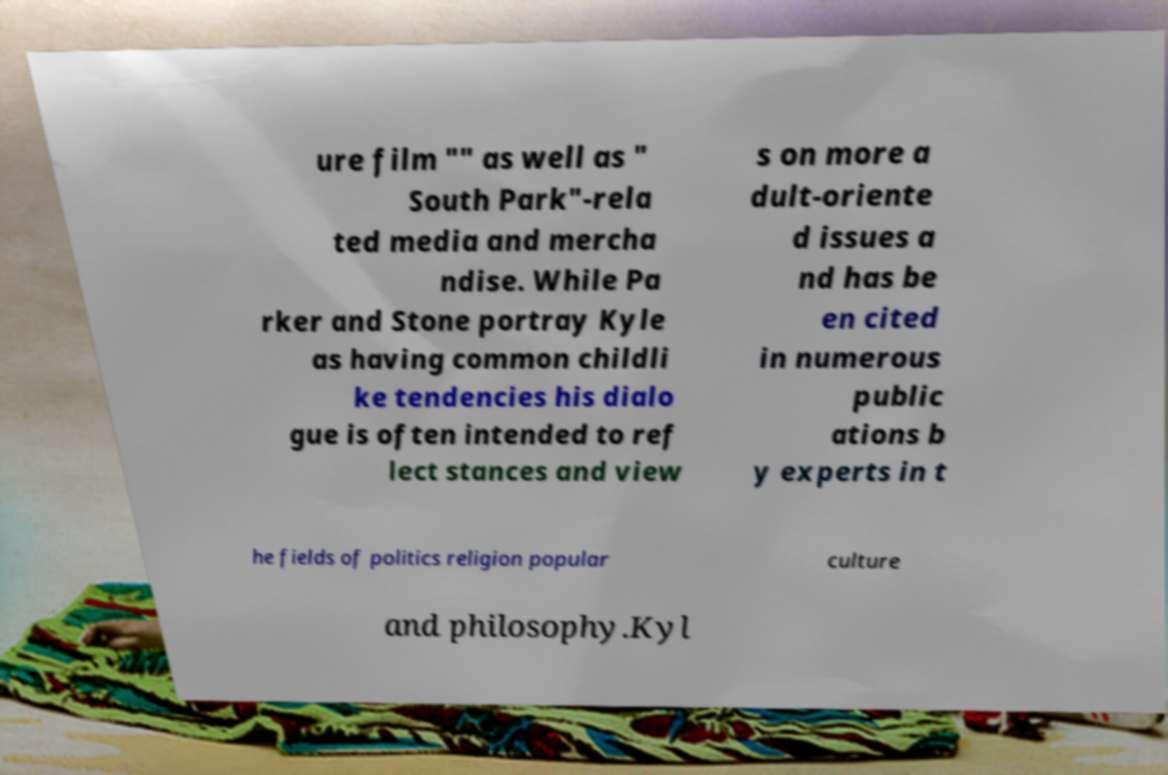Please read and relay the text visible in this image. What does it say? ure film "" as well as " South Park"-rela ted media and mercha ndise. While Pa rker and Stone portray Kyle as having common childli ke tendencies his dialo gue is often intended to ref lect stances and view s on more a dult-oriente d issues a nd has be en cited in numerous public ations b y experts in t he fields of politics religion popular culture and philosophy.Kyl 